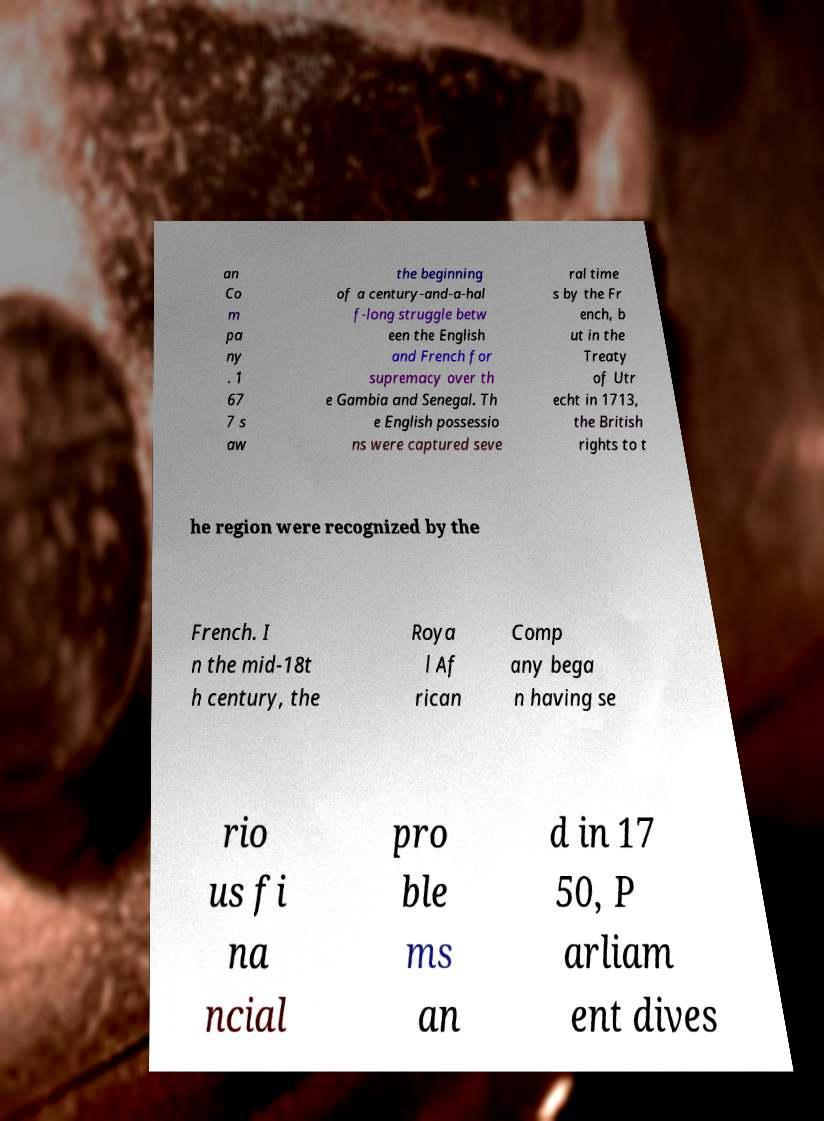Can you read and provide the text displayed in the image?This photo seems to have some interesting text. Can you extract and type it out for me? an Co m pa ny . 1 67 7 s aw the beginning of a century-and-a-hal f-long struggle betw een the English and French for supremacy over th e Gambia and Senegal. Th e English possessio ns were captured seve ral time s by the Fr ench, b ut in the Treaty of Utr echt in 1713, the British rights to t he region were recognized by the French. I n the mid-18t h century, the Roya l Af rican Comp any bega n having se rio us fi na ncial pro ble ms an d in 17 50, P arliam ent dives 